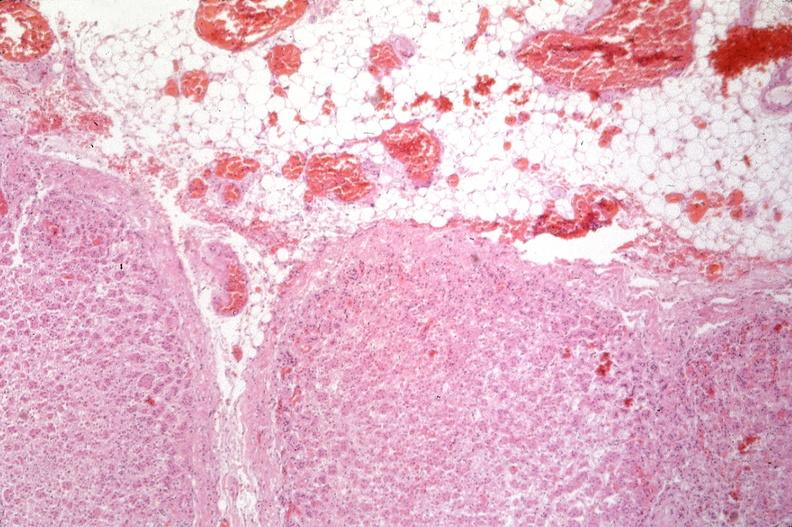where is this?
Answer the question using a single word or phrase. Pancreas 